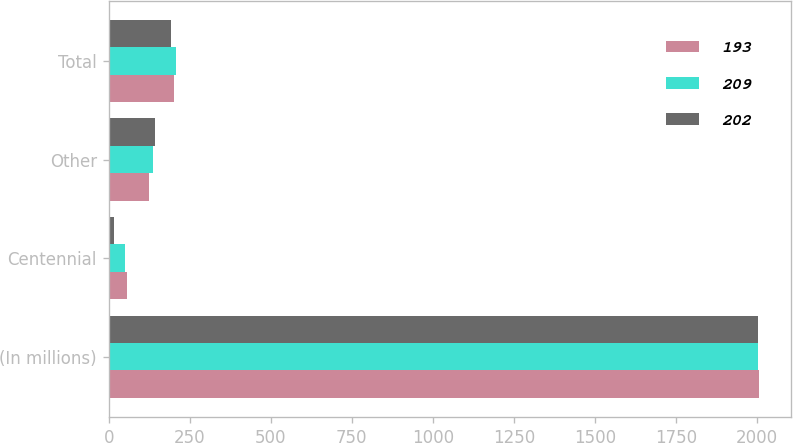<chart> <loc_0><loc_0><loc_500><loc_500><stacked_bar_chart><ecel><fcel>(In millions)<fcel>Centennial<fcel>Other<fcel>Total<nl><fcel>193<fcel>2004<fcel>56<fcel>124<fcel>202<nl><fcel>209<fcel>2003<fcel>49<fcel>136<fcel>209<nl><fcel>202<fcel>2002<fcel>16<fcel>144<fcel>193<nl></chart> 